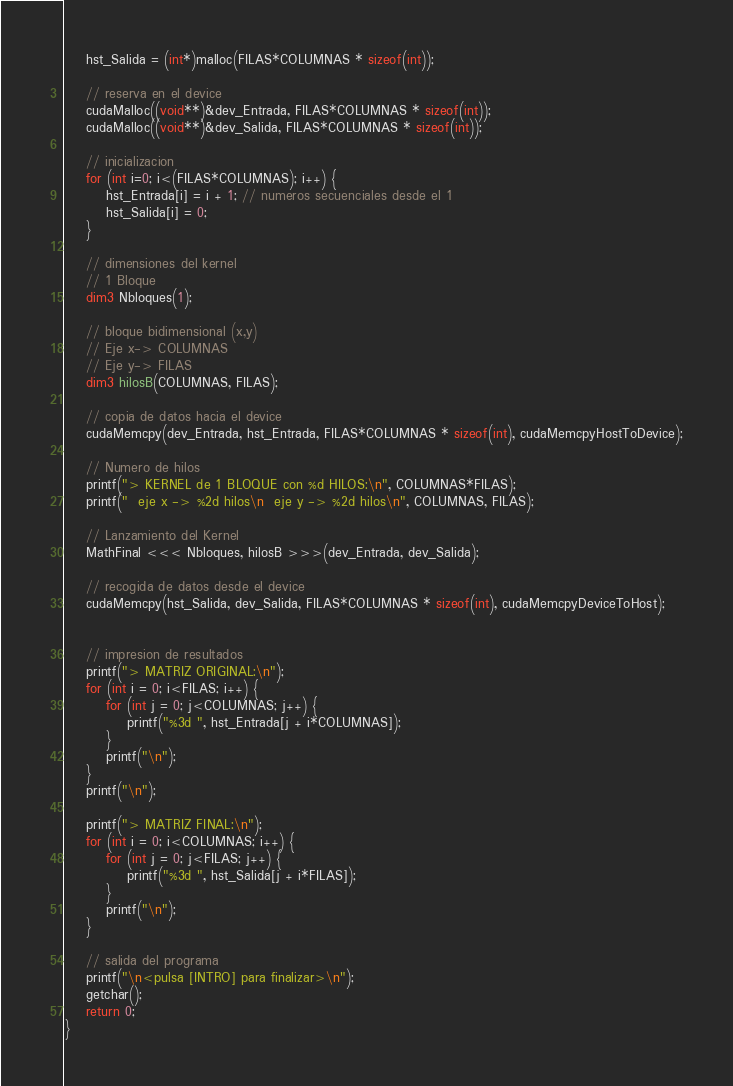Convert code to text. <code><loc_0><loc_0><loc_500><loc_500><_Cuda_>    hst_Salida = (int*)malloc(FILAS*COLUMNAS * sizeof(int));

    // reserva en el device
    cudaMalloc((void**)&dev_Entrada, FILAS*COLUMNAS * sizeof(int));
    cudaMalloc((void**)&dev_Salida, FILAS*COLUMNAS * sizeof(int));

    // inicializacion
    for (int i=0; i<(FILAS*COLUMNAS); i++) {
        hst_Entrada[i] = i + 1; // numeros secuenciales desde el 1
        hst_Salida[i] = 0;
    }

    // dimensiones del kernel
    // 1 Bloque
    dim3 Nbloques(1);

    // bloque bidimensional (x,y)
    // Eje x-> COLUMNAS
    // Eje y-> FILAS
    dim3 hilosB(COLUMNAS, FILAS);

    // copia de datos hacia el device
    cudaMemcpy(dev_Entrada, hst_Entrada, FILAS*COLUMNAS * sizeof(int), cudaMemcpyHostToDevice);

    // Numero de hilos
    printf("> KERNEL de 1 BLOQUE con %d HILOS:\n", COLUMNAS*FILAS);
    printf("  eje x -> %2d hilos\n  eje y -> %2d hilos\n", COLUMNAS, FILAS);

    // Lanzamiento del Kernel
    MathFinal <<< Nbloques, hilosB >>>(dev_Entrada, dev_Salida);

    // recogida de datos desde el device
    cudaMemcpy(hst_Salida, dev_Salida, FILAS*COLUMNAS * sizeof(int), cudaMemcpyDeviceToHost);


    // impresion de resultados
    printf("> MATRIZ ORIGINAL:\n");
    for (int i = 0; i<FILAS; i++) {
        for (int j = 0; j<COLUMNAS; j++) {
            printf("%3d ", hst_Entrada[j + i*COLUMNAS]);
        }
        printf("\n");
    }
    printf("\n");

    printf("> MATRIZ FINAL:\n");
    for (int i = 0; i<COLUMNAS; i++) {
        for (int j = 0; j<FILAS; j++) {
            printf("%3d ", hst_Salida[j + i*FILAS]);
        }
        printf("\n");
    }

    // salida del programa
    printf("\n<pulsa [INTRO] para finalizar>\n");
    getchar();
    return 0;
}
</code> 